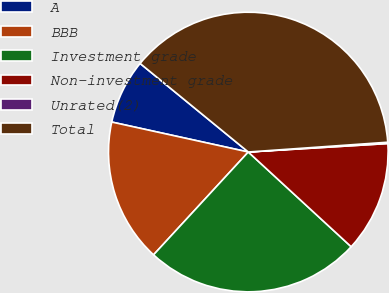Convert chart to OTSL. <chart><loc_0><loc_0><loc_500><loc_500><pie_chart><fcel>A<fcel>BBB<fcel>Investment grade<fcel>Non-investment grade<fcel>Unrated(2)<fcel>Total<nl><fcel>7.48%<fcel>16.59%<fcel>25.01%<fcel>12.81%<fcel>0.15%<fcel>37.97%<nl></chart> 